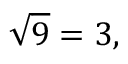Convert formula to latex. <formula><loc_0><loc_0><loc_500><loc_500>{ \sqrt { 9 } } = 3 ,</formula> 